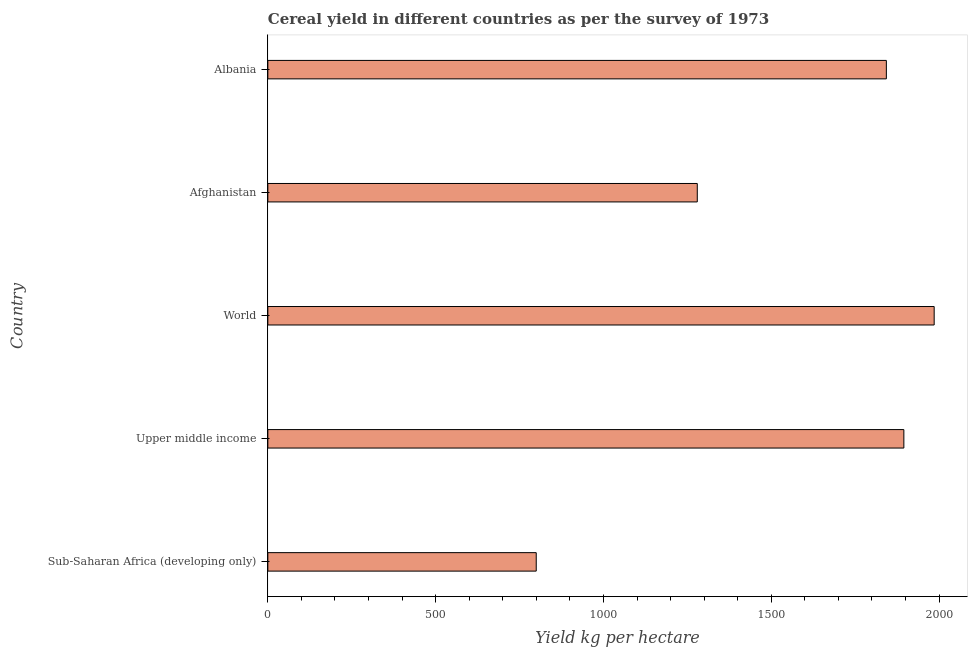What is the title of the graph?
Provide a short and direct response. Cereal yield in different countries as per the survey of 1973. What is the label or title of the X-axis?
Offer a terse response. Yield kg per hectare. What is the cereal yield in Sub-Saharan Africa (developing only)?
Your answer should be compact. 799.72. Across all countries, what is the maximum cereal yield?
Your answer should be very brief. 1985.44. Across all countries, what is the minimum cereal yield?
Your answer should be compact. 799.72. In which country was the cereal yield minimum?
Make the answer very short. Sub-Saharan Africa (developing only). What is the sum of the cereal yield?
Keep it short and to the point. 7802.81. What is the difference between the cereal yield in Albania and World?
Provide a short and direct response. -142.49. What is the average cereal yield per country?
Offer a very short reply. 1560.56. What is the median cereal yield?
Your answer should be compact. 1842.95. What is the ratio of the cereal yield in Albania to that in Upper middle income?
Give a very brief answer. 0.97. Is the cereal yield in Albania less than that in Sub-Saharan Africa (developing only)?
Your answer should be compact. No. What is the difference between the highest and the second highest cereal yield?
Provide a short and direct response. 90.34. Is the sum of the cereal yield in Afghanistan and World greater than the maximum cereal yield across all countries?
Offer a very short reply. Yes. What is the difference between the highest and the lowest cereal yield?
Your response must be concise. 1185.72. How many bars are there?
Keep it short and to the point. 5. How many countries are there in the graph?
Your response must be concise. 5. What is the difference between two consecutive major ticks on the X-axis?
Your answer should be very brief. 500. Are the values on the major ticks of X-axis written in scientific E-notation?
Offer a very short reply. No. What is the Yield kg per hectare in Sub-Saharan Africa (developing only)?
Give a very brief answer. 799.72. What is the Yield kg per hectare in Upper middle income?
Provide a succinct answer. 1895.1. What is the Yield kg per hectare in World?
Offer a very short reply. 1985.44. What is the Yield kg per hectare in Afghanistan?
Offer a very short reply. 1279.59. What is the Yield kg per hectare in Albania?
Provide a short and direct response. 1842.95. What is the difference between the Yield kg per hectare in Sub-Saharan Africa (developing only) and Upper middle income?
Ensure brevity in your answer.  -1095.39. What is the difference between the Yield kg per hectare in Sub-Saharan Africa (developing only) and World?
Keep it short and to the point. -1185.72. What is the difference between the Yield kg per hectare in Sub-Saharan Africa (developing only) and Afghanistan?
Make the answer very short. -479.87. What is the difference between the Yield kg per hectare in Sub-Saharan Africa (developing only) and Albania?
Offer a terse response. -1043.23. What is the difference between the Yield kg per hectare in Upper middle income and World?
Offer a terse response. -90.34. What is the difference between the Yield kg per hectare in Upper middle income and Afghanistan?
Provide a short and direct response. 615.51. What is the difference between the Yield kg per hectare in Upper middle income and Albania?
Provide a succinct answer. 52.15. What is the difference between the Yield kg per hectare in World and Afghanistan?
Your answer should be compact. 705.85. What is the difference between the Yield kg per hectare in World and Albania?
Your answer should be compact. 142.49. What is the difference between the Yield kg per hectare in Afghanistan and Albania?
Keep it short and to the point. -563.36. What is the ratio of the Yield kg per hectare in Sub-Saharan Africa (developing only) to that in Upper middle income?
Your answer should be very brief. 0.42. What is the ratio of the Yield kg per hectare in Sub-Saharan Africa (developing only) to that in World?
Offer a terse response. 0.4. What is the ratio of the Yield kg per hectare in Sub-Saharan Africa (developing only) to that in Albania?
Ensure brevity in your answer.  0.43. What is the ratio of the Yield kg per hectare in Upper middle income to that in World?
Your response must be concise. 0.95. What is the ratio of the Yield kg per hectare in Upper middle income to that in Afghanistan?
Your response must be concise. 1.48. What is the ratio of the Yield kg per hectare in Upper middle income to that in Albania?
Your response must be concise. 1.03. What is the ratio of the Yield kg per hectare in World to that in Afghanistan?
Offer a very short reply. 1.55. What is the ratio of the Yield kg per hectare in World to that in Albania?
Offer a terse response. 1.08. What is the ratio of the Yield kg per hectare in Afghanistan to that in Albania?
Give a very brief answer. 0.69. 